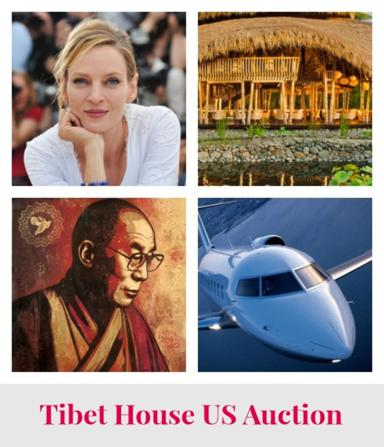Can you describe the collage of photos in the image? The collage contains four distinct images: a portrait of a woman who appears thoughtful, a serene hut beside a body of water signifying a travel destination, an aircraft which might indicate luxury travel or experiences, and a religious or cultural painting of what looks to be a Tibetan monk. Each of these photos suggests different aspects of life and culture that could be relevant to the themes celebrated in the auction. 